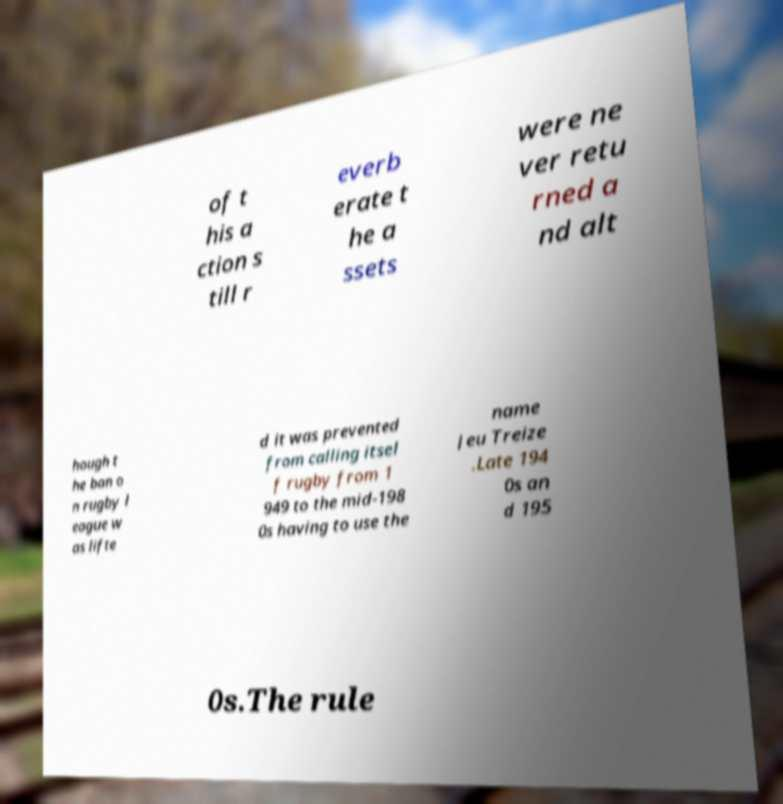For documentation purposes, I need the text within this image transcribed. Could you provide that? of t his a ction s till r everb erate t he a ssets were ne ver retu rned a nd alt hough t he ban o n rugby l eague w as lifte d it was prevented from calling itsel f rugby from 1 949 to the mid-198 0s having to use the name Jeu Treize .Late 194 0s an d 195 0s.The rule 